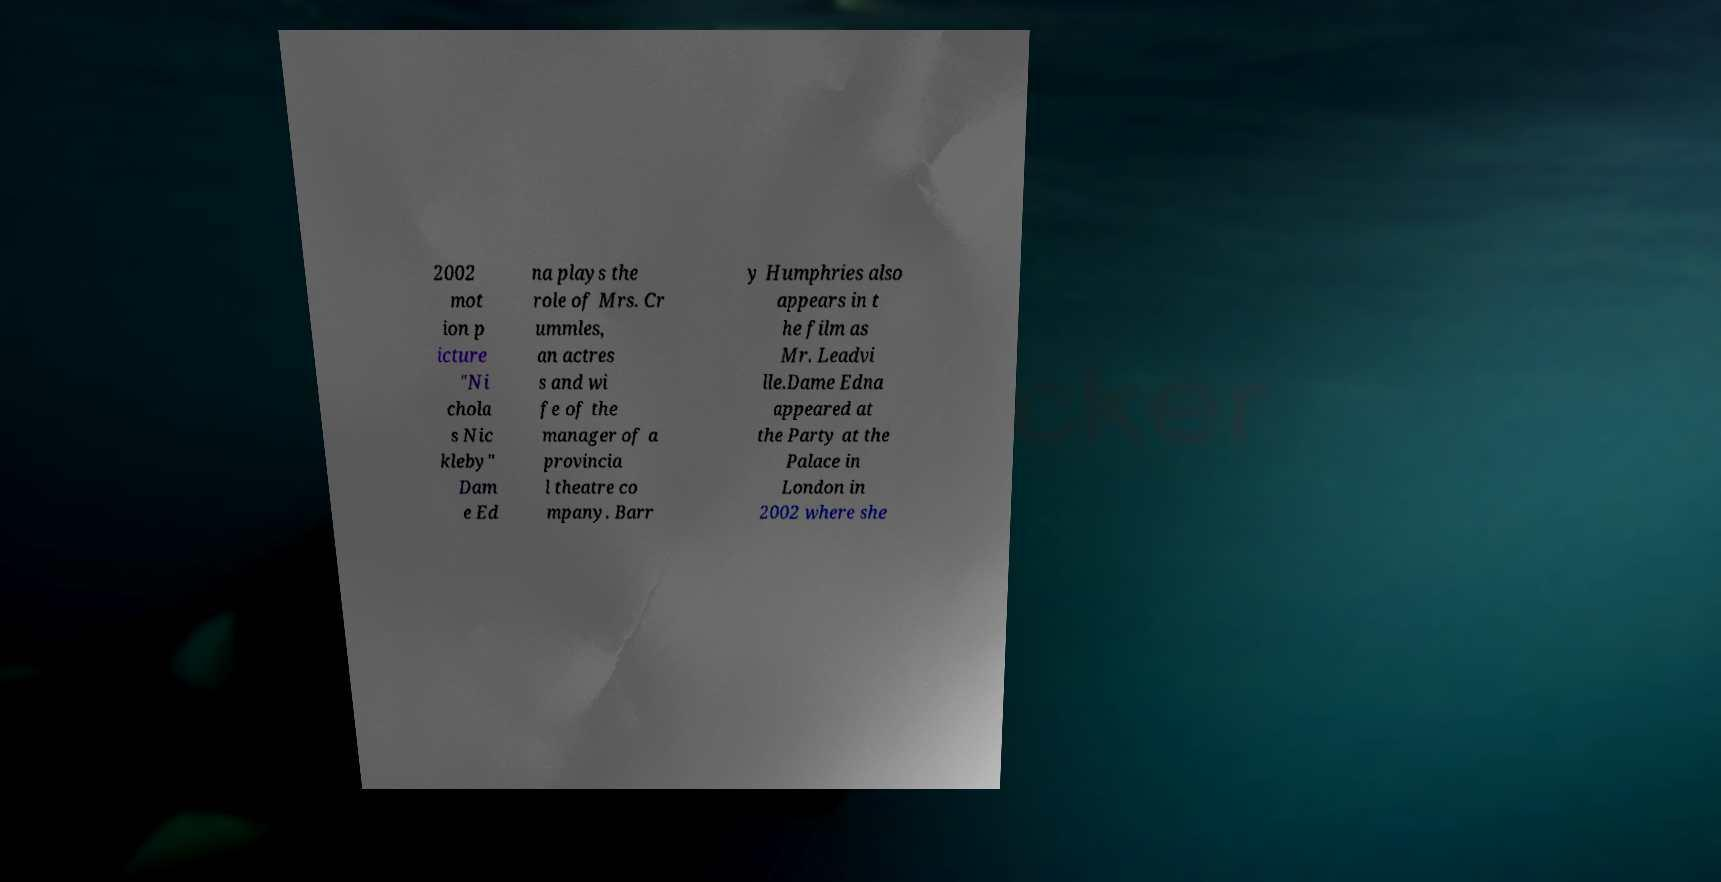Can you accurately transcribe the text from the provided image for me? 2002 mot ion p icture "Ni chola s Nic kleby" Dam e Ed na plays the role of Mrs. Cr ummles, an actres s and wi fe of the manager of a provincia l theatre co mpany. Barr y Humphries also appears in t he film as Mr. Leadvi lle.Dame Edna appeared at the Party at the Palace in London in 2002 where she 